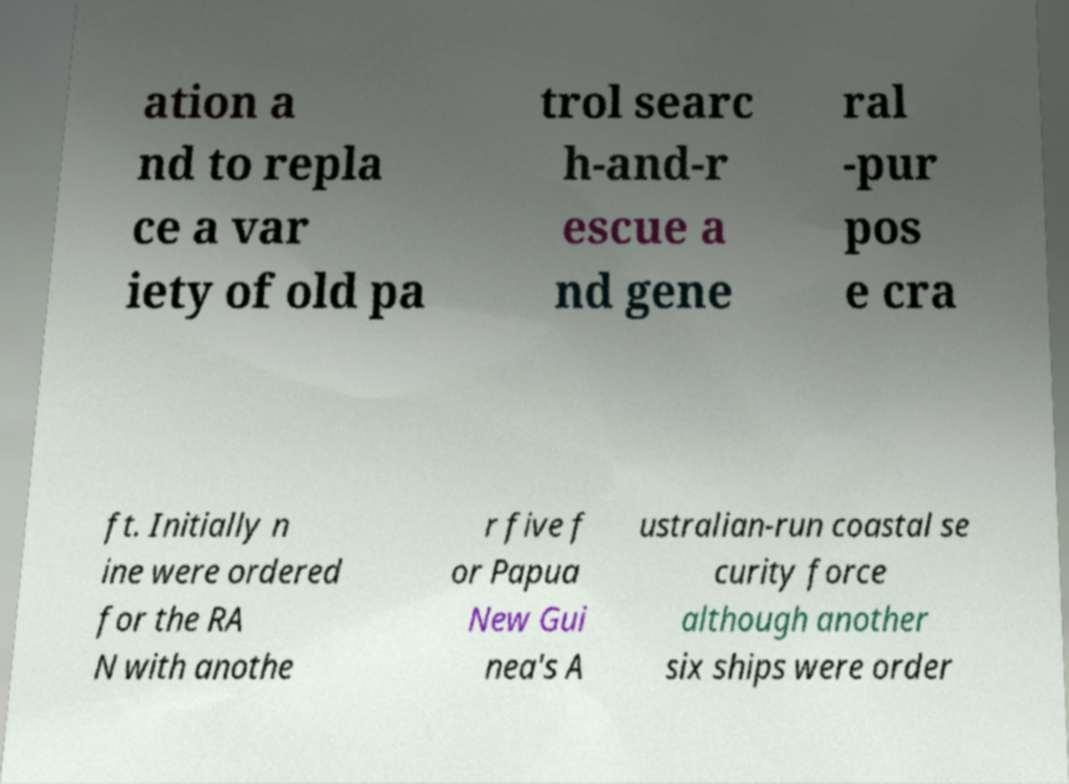Could you assist in decoding the text presented in this image and type it out clearly? ation a nd to repla ce a var iety of old pa trol searc h-and-r escue a nd gene ral -pur pos e cra ft. Initially n ine were ordered for the RA N with anothe r five f or Papua New Gui nea's A ustralian-run coastal se curity force although another six ships were order 